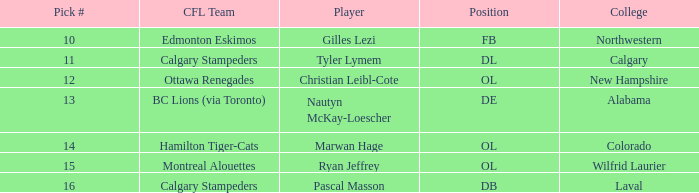What number is assigned for picking northwestern college? 10.0. Could you parse the entire table as a dict? {'header': ['Pick #', 'CFL Team', 'Player', 'Position', 'College'], 'rows': [['10', 'Edmonton Eskimos', 'Gilles Lezi', 'FB', 'Northwestern'], ['11', 'Calgary Stampeders', 'Tyler Lymem', 'DL', 'Calgary'], ['12', 'Ottawa Renegades', 'Christian Leibl-Cote', 'OL', 'New Hampshire'], ['13', 'BC Lions (via Toronto)', 'Nautyn McKay-Loescher', 'DE', 'Alabama'], ['14', 'Hamilton Tiger-Cats', 'Marwan Hage', 'OL', 'Colorado'], ['15', 'Montreal Alouettes', 'Ryan Jeffrey', 'OL', 'Wilfrid Laurier'], ['16', 'Calgary Stampeders', 'Pascal Masson', 'DB', 'Laval']]} 